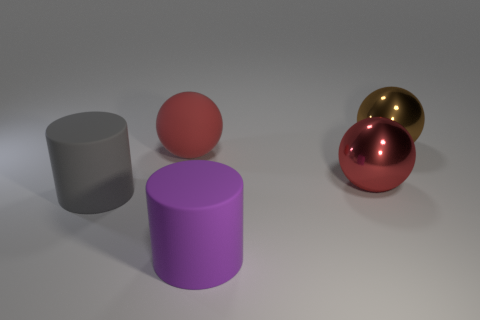What number of large green shiny spheres are there? 0 